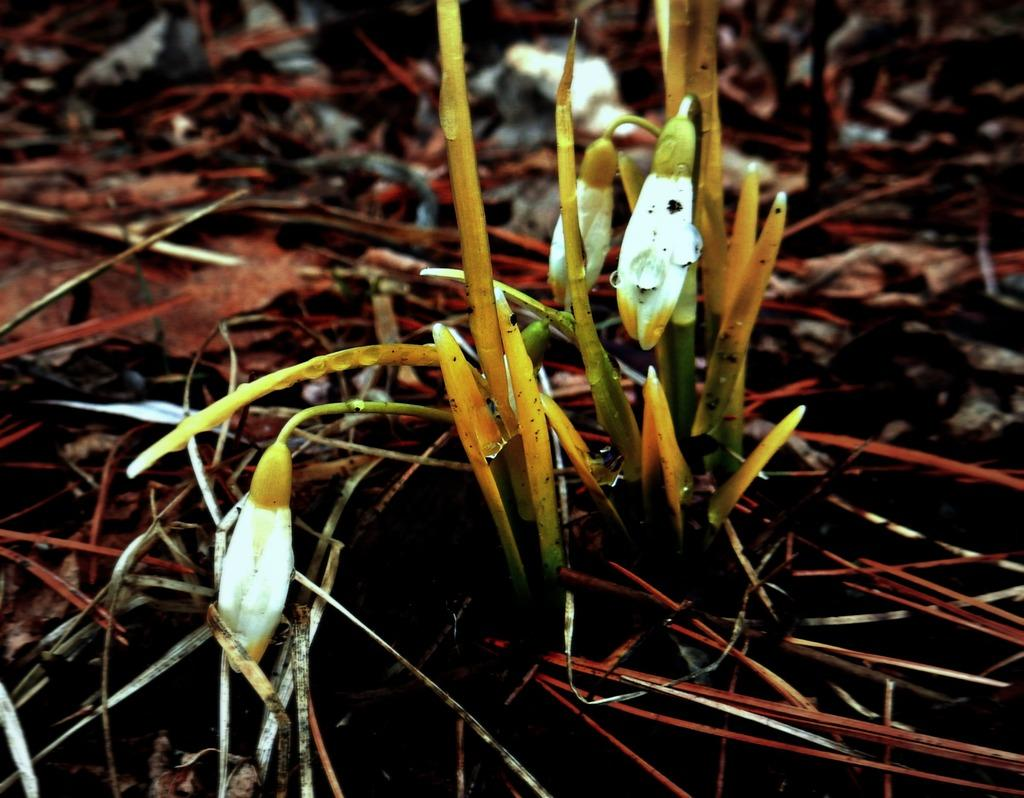What type of vegetation can be seen in the image? There is grass in the image. What other type of plant is visible in the image? There is a plant in the image. What stage of growth are the plant's flowers in the image? There are buds in the image. What type of comb is used to groom the plant in the image? There is no comb present in the image, and plants do not require grooming with a comb. What type of scale can be seen on the plant in the image? There is no scale present on the plant in the image, as scales are not a characteristic of the plant. 